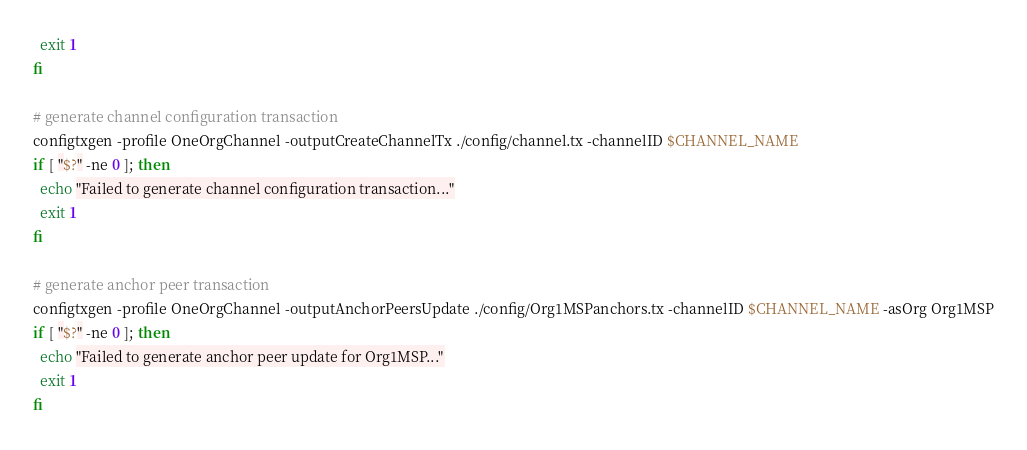<code> <loc_0><loc_0><loc_500><loc_500><_Bash_>  exit 1
fi

# generate channel configuration transaction
configtxgen -profile OneOrgChannel -outputCreateChannelTx ./config/channel.tx -channelID $CHANNEL_NAME
if [ "$?" -ne 0 ]; then
  echo "Failed to generate channel configuration transaction..."
  exit 1
fi

# generate anchor peer transaction
configtxgen -profile OneOrgChannel -outputAnchorPeersUpdate ./config/Org1MSPanchors.tx -channelID $CHANNEL_NAME -asOrg Org1MSP
if [ "$?" -ne 0 ]; then
  echo "Failed to generate anchor peer update for Org1MSP..."
  exit 1
fi
</code> 